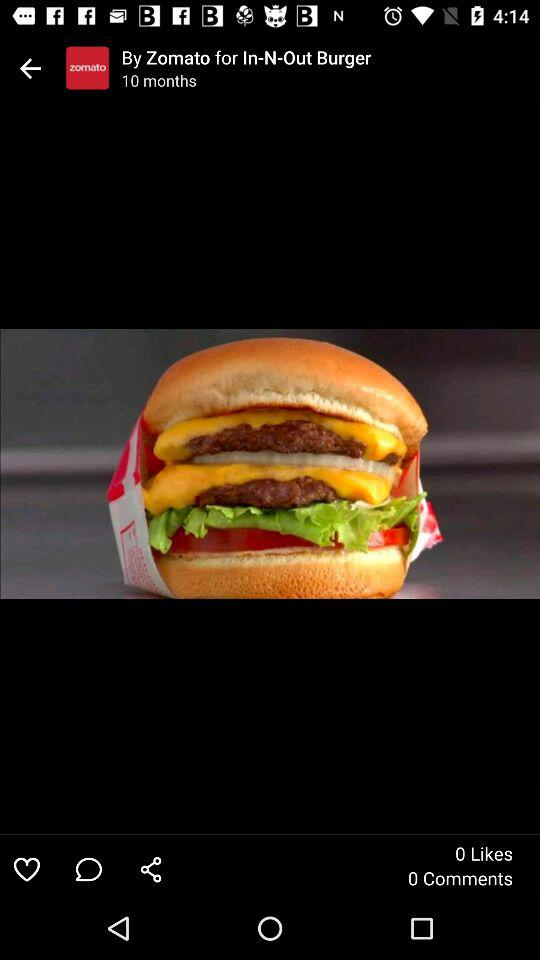How many likes does the burger have?
Answer the question using a single word or phrase. 0 